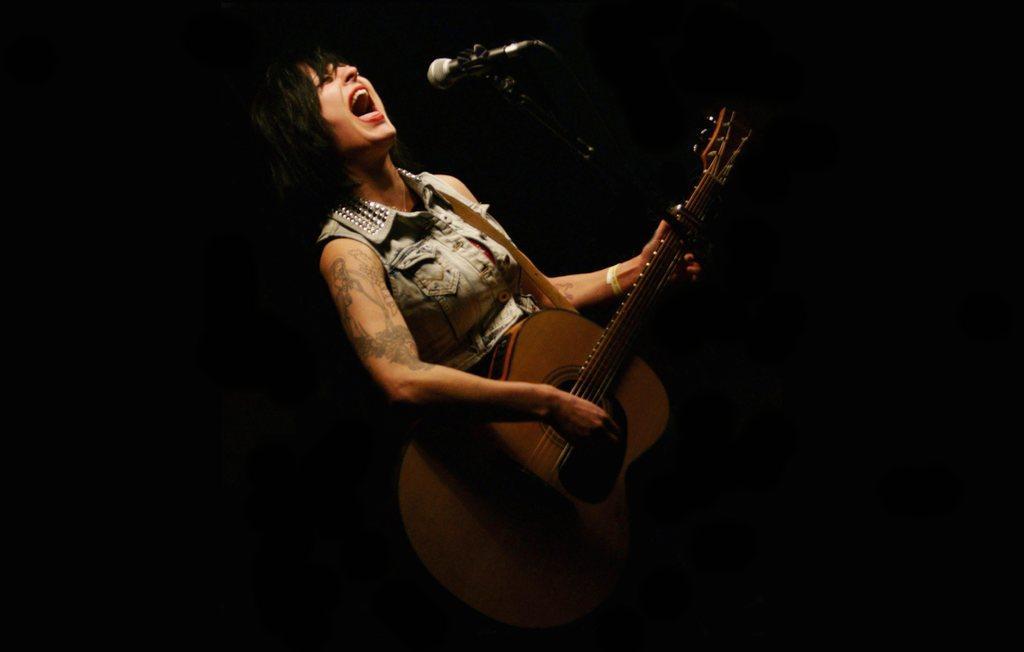Please provide a concise description of this image. In this Image I see a woman who is in front of the mic and she is holding a guitar in her hands and It is dark in the background. 